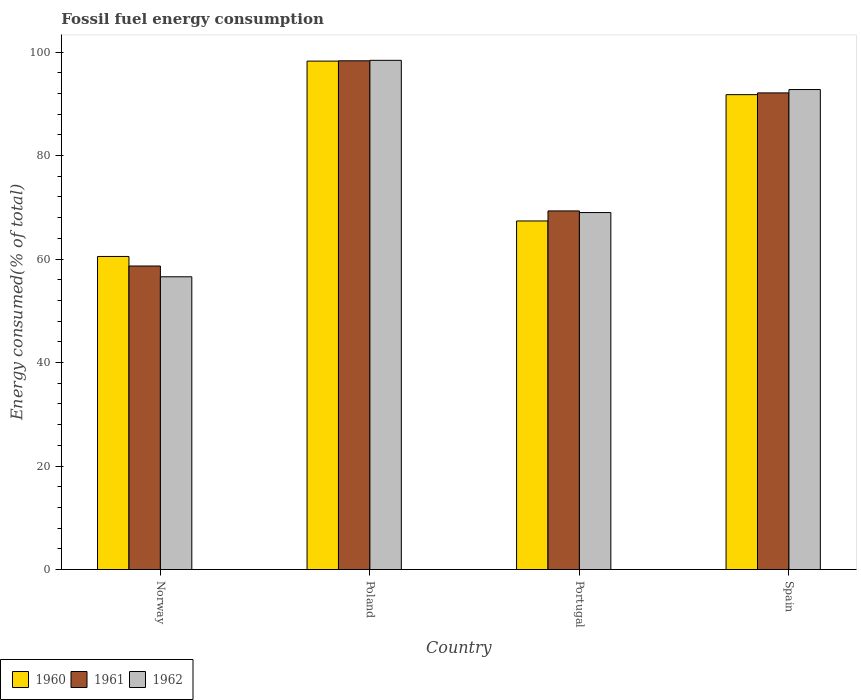How many different coloured bars are there?
Your answer should be very brief. 3. How many groups of bars are there?
Keep it short and to the point. 4. Are the number of bars per tick equal to the number of legend labels?
Offer a very short reply. Yes. Are the number of bars on each tick of the X-axis equal?
Provide a short and direct response. Yes. How many bars are there on the 1st tick from the right?
Provide a short and direct response. 3. In how many cases, is the number of bars for a given country not equal to the number of legend labels?
Make the answer very short. 0. What is the percentage of energy consumed in 1960 in Poland?
Your answer should be compact. 98.25. Across all countries, what is the maximum percentage of energy consumed in 1960?
Offer a terse response. 98.25. Across all countries, what is the minimum percentage of energy consumed in 1961?
Your answer should be very brief. 58.65. In which country was the percentage of energy consumed in 1961 minimum?
Your response must be concise. Norway. What is the total percentage of energy consumed in 1960 in the graph?
Ensure brevity in your answer.  317.87. What is the difference between the percentage of energy consumed in 1962 in Norway and that in Spain?
Your answer should be compact. -36.18. What is the difference between the percentage of energy consumed in 1962 in Poland and the percentage of energy consumed in 1960 in Spain?
Your response must be concise. 6.63. What is the average percentage of energy consumed in 1960 per country?
Give a very brief answer. 79.47. What is the difference between the percentage of energy consumed of/in 1962 and percentage of energy consumed of/in 1960 in Spain?
Give a very brief answer. 0.99. What is the ratio of the percentage of energy consumed in 1961 in Portugal to that in Spain?
Ensure brevity in your answer.  0.75. Is the difference between the percentage of energy consumed in 1962 in Norway and Spain greater than the difference between the percentage of energy consumed in 1960 in Norway and Spain?
Provide a succinct answer. No. What is the difference between the highest and the second highest percentage of energy consumed in 1961?
Keep it short and to the point. 6.2. What is the difference between the highest and the lowest percentage of energy consumed in 1960?
Keep it short and to the point. 37.75. In how many countries, is the percentage of energy consumed in 1962 greater than the average percentage of energy consumed in 1962 taken over all countries?
Your response must be concise. 2. What does the 2nd bar from the right in Norway represents?
Offer a terse response. 1961. Are all the bars in the graph horizontal?
Keep it short and to the point. No. What is the difference between two consecutive major ticks on the Y-axis?
Your answer should be very brief. 20. Are the values on the major ticks of Y-axis written in scientific E-notation?
Make the answer very short. No. Does the graph contain any zero values?
Provide a short and direct response. No. Where does the legend appear in the graph?
Your answer should be very brief. Bottom left. What is the title of the graph?
Provide a short and direct response. Fossil fuel energy consumption. Does "1965" appear as one of the legend labels in the graph?
Provide a short and direct response. No. What is the label or title of the X-axis?
Offer a terse response. Country. What is the label or title of the Y-axis?
Keep it short and to the point. Energy consumed(% of total). What is the Energy consumed(% of total) of 1960 in Norway?
Your answer should be compact. 60.5. What is the Energy consumed(% of total) of 1961 in Norway?
Keep it short and to the point. 58.65. What is the Energy consumed(% of total) in 1962 in Norway?
Provide a succinct answer. 56.57. What is the Energy consumed(% of total) of 1960 in Poland?
Your answer should be very brief. 98.25. What is the Energy consumed(% of total) in 1961 in Poland?
Provide a succinct answer. 98.3. What is the Energy consumed(% of total) of 1962 in Poland?
Ensure brevity in your answer.  98.4. What is the Energy consumed(% of total) of 1960 in Portugal?
Provide a succinct answer. 67.36. What is the Energy consumed(% of total) of 1961 in Portugal?
Offer a very short reply. 69.3. What is the Energy consumed(% of total) in 1962 in Portugal?
Provide a succinct answer. 68.98. What is the Energy consumed(% of total) in 1960 in Spain?
Offer a terse response. 91.77. What is the Energy consumed(% of total) of 1961 in Spain?
Provide a succinct answer. 92.1. What is the Energy consumed(% of total) of 1962 in Spain?
Keep it short and to the point. 92.75. Across all countries, what is the maximum Energy consumed(% of total) of 1960?
Offer a terse response. 98.25. Across all countries, what is the maximum Energy consumed(% of total) in 1961?
Offer a terse response. 98.3. Across all countries, what is the maximum Energy consumed(% of total) in 1962?
Make the answer very short. 98.4. Across all countries, what is the minimum Energy consumed(% of total) of 1960?
Your answer should be very brief. 60.5. Across all countries, what is the minimum Energy consumed(% of total) of 1961?
Offer a terse response. 58.65. Across all countries, what is the minimum Energy consumed(% of total) of 1962?
Keep it short and to the point. 56.57. What is the total Energy consumed(% of total) of 1960 in the graph?
Ensure brevity in your answer.  317.87. What is the total Energy consumed(% of total) of 1961 in the graph?
Your answer should be compact. 318.36. What is the total Energy consumed(% of total) of 1962 in the graph?
Make the answer very short. 316.7. What is the difference between the Energy consumed(% of total) in 1960 in Norway and that in Poland?
Provide a succinct answer. -37.75. What is the difference between the Energy consumed(% of total) in 1961 in Norway and that in Poland?
Keep it short and to the point. -39.65. What is the difference between the Energy consumed(% of total) in 1962 in Norway and that in Poland?
Your answer should be very brief. -41.83. What is the difference between the Energy consumed(% of total) in 1960 in Norway and that in Portugal?
Offer a terse response. -6.86. What is the difference between the Energy consumed(% of total) of 1961 in Norway and that in Portugal?
Your response must be concise. -10.64. What is the difference between the Energy consumed(% of total) of 1962 in Norway and that in Portugal?
Keep it short and to the point. -12.41. What is the difference between the Energy consumed(% of total) in 1960 in Norway and that in Spain?
Ensure brevity in your answer.  -31.27. What is the difference between the Energy consumed(% of total) in 1961 in Norway and that in Spain?
Keep it short and to the point. -33.45. What is the difference between the Energy consumed(% of total) in 1962 in Norway and that in Spain?
Keep it short and to the point. -36.18. What is the difference between the Energy consumed(% of total) in 1960 in Poland and that in Portugal?
Your answer should be very brief. 30.89. What is the difference between the Energy consumed(% of total) of 1961 in Poland and that in Portugal?
Your answer should be compact. 29.01. What is the difference between the Energy consumed(% of total) in 1962 in Poland and that in Portugal?
Your response must be concise. 29.42. What is the difference between the Energy consumed(% of total) of 1960 in Poland and that in Spain?
Offer a terse response. 6.48. What is the difference between the Energy consumed(% of total) in 1961 in Poland and that in Spain?
Ensure brevity in your answer.  6.2. What is the difference between the Energy consumed(% of total) in 1962 in Poland and that in Spain?
Give a very brief answer. 5.64. What is the difference between the Energy consumed(% of total) in 1960 in Portugal and that in Spain?
Ensure brevity in your answer.  -24.41. What is the difference between the Energy consumed(% of total) in 1961 in Portugal and that in Spain?
Provide a succinct answer. -22.81. What is the difference between the Energy consumed(% of total) of 1962 in Portugal and that in Spain?
Offer a very short reply. -23.77. What is the difference between the Energy consumed(% of total) in 1960 in Norway and the Energy consumed(% of total) in 1961 in Poland?
Make the answer very short. -37.81. What is the difference between the Energy consumed(% of total) of 1960 in Norway and the Energy consumed(% of total) of 1962 in Poland?
Provide a succinct answer. -37.9. What is the difference between the Energy consumed(% of total) of 1961 in Norway and the Energy consumed(% of total) of 1962 in Poland?
Ensure brevity in your answer.  -39.74. What is the difference between the Energy consumed(% of total) in 1960 in Norway and the Energy consumed(% of total) in 1961 in Portugal?
Offer a terse response. -8.8. What is the difference between the Energy consumed(% of total) in 1960 in Norway and the Energy consumed(% of total) in 1962 in Portugal?
Keep it short and to the point. -8.48. What is the difference between the Energy consumed(% of total) of 1961 in Norway and the Energy consumed(% of total) of 1962 in Portugal?
Offer a terse response. -10.33. What is the difference between the Energy consumed(% of total) of 1960 in Norway and the Energy consumed(% of total) of 1961 in Spain?
Offer a terse response. -31.61. What is the difference between the Energy consumed(% of total) in 1960 in Norway and the Energy consumed(% of total) in 1962 in Spain?
Offer a terse response. -32.26. What is the difference between the Energy consumed(% of total) in 1961 in Norway and the Energy consumed(% of total) in 1962 in Spain?
Provide a succinct answer. -34.1. What is the difference between the Energy consumed(% of total) of 1960 in Poland and the Energy consumed(% of total) of 1961 in Portugal?
Provide a short and direct response. 28.95. What is the difference between the Energy consumed(% of total) in 1960 in Poland and the Energy consumed(% of total) in 1962 in Portugal?
Keep it short and to the point. 29.27. What is the difference between the Energy consumed(% of total) in 1961 in Poland and the Energy consumed(% of total) in 1962 in Portugal?
Provide a short and direct response. 29.32. What is the difference between the Energy consumed(% of total) in 1960 in Poland and the Energy consumed(% of total) in 1961 in Spain?
Provide a short and direct response. 6.14. What is the difference between the Energy consumed(% of total) of 1960 in Poland and the Energy consumed(% of total) of 1962 in Spain?
Your answer should be compact. 5.49. What is the difference between the Energy consumed(% of total) in 1961 in Poland and the Energy consumed(% of total) in 1962 in Spain?
Your answer should be compact. 5.55. What is the difference between the Energy consumed(% of total) of 1960 in Portugal and the Energy consumed(% of total) of 1961 in Spain?
Provide a short and direct response. -24.75. What is the difference between the Energy consumed(% of total) of 1960 in Portugal and the Energy consumed(% of total) of 1962 in Spain?
Your response must be concise. -25.4. What is the difference between the Energy consumed(% of total) in 1961 in Portugal and the Energy consumed(% of total) in 1962 in Spain?
Your answer should be compact. -23.46. What is the average Energy consumed(% of total) of 1960 per country?
Offer a terse response. 79.47. What is the average Energy consumed(% of total) in 1961 per country?
Give a very brief answer. 79.59. What is the average Energy consumed(% of total) in 1962 per country?
Ensure brevity in your answer.  79.17. What is the difference between the Energy consumed(% of total) of 1960 and Energy consumed(% of total) of 1961 in Norway?
Provide a succinct answer. 1.85. What is the difference between the Energy consumed(% of total) of 1960 and Energy consumed(% of total) of 1962 in Norway?
Provide a short and direct response. 3.93. What is the difference between the Energy consumed(% of total) in 1961 and Energy consumed(% of total) in 1962 in Norway?
Your answer should be compact. 2.08. What is the difference between the Energy consumed(% of total) in 1960 and Energy consumed(% of total) in 1961 in Poland?
Ensure brevity in your answer.  -0.06. What is the difference between the Energy consumed(% of total) in 1960 and Energy consumed(% of total) in 1962 in Poland?
Your response must be concise. -0.15. What is the difference between the Energy consumed(% of total) of 1961 and Energy consumed(% of total) of 1962 in Poland?
Offer a terse response. -0.09. What is the difference between the Energy consumed(% of total) of 1960 and Energy consumed(% of total) of 1961 in Portugal?
Provide a short and direct response. -1.94. What is the difference between the Energy consumed(% of total) of 1960 and Energy consumed(% of total) of 1962 in Portugal?
Make the answer very short. -1.62. What is the difference between the Energy consumed(% of total) of 1961 and Energy consumed(% of total) of 1962 in Portugal?
Ensure brevity in your answer.  0.32. What is the difference between the Energy consumed(% of total) in 1960 and Energy consumed(% of total) in 1961 in Spain?
Your response must be concise. -0.34. What is the difference between the Energy consumed(% of total) of 1960 and Energy consumed(% of total) of 1962 in Spain?
Offer a terse response. -0.99. What is the difference between the Energy consumed(% of total) in 1961 and Energy consumed(% of total) in 1962 in Spain?
Offer a terse response. -0.65. What is the ratio of the Energy consumed(% of total) of 1960 in Norway to that in Poland?
Make the answer very short. 0.62. What is the ratio of the Energy consumed(% of total) in 1961 in Norway to that in Poland?
Your answer should be very brief. 0.6. What is the ratio of the Energy consumed(% of total) in 1962 in Norway to that in Poland?
Offer a terse response. 0.57. What is the ratio of the Energy consumed(% of total) in 1960 in Norway to that in Portugal?
Keep it short and to the point. 0.9. What is the ratio of the Energy consumed(% of total) of 1961 in Norway to that in Portugal?
Offer a very short reply. 0.85. What is the ratio of the Energy consumed(% of total) of 1962 in Norway to that in Portugal?
Your answer should be very brief. 0.82. What is the ratio of the Energy consumed(% of total) of 1960 in Norway to that in Spain?
Offer a very short reply. 0.66. What is the ratio of the Energy consumed(% of total) in 1961 in Norway to that in Spain?
Offer a terse response. 0.64. What is the ratio of the Energy consumed(% of total) of 1962 in Norway to that in Spain?
Ensure brevity in your answer.  0.61. What is the ratio of the Energy consumed(% of total) in 1960 in Poland to that in Portugal?
Your answer should be very brief. 1.46. What is the ratio of the Energy consumed(% of total) in 1961 in Poland to that in Portugal?
Ensure brevity in your answer.  1.42. What is the ratio of the Energy consumed(% of total) of 1962 in Poland to that in Portugal?
Your answer should be very brief. 1.43. What is the ratio of the Energy consumed(% of total) in 1960 in Poland to that in Spain?
Your answer should be very brief. 1.07. What is the ratio of the Energy consumed(% of total) of 1961 in Poland to that in Spain?
Your answer should be very brief. 1.07. What is the ratio of the Energy consumed(% of total) of 1962 in Poland to that in Spain?
Provide a succinct answer. 1.06. What is the ratio of the Energy consumed(% of total) in 1960 in Portugal to that in Spain?
Your answer should be very brief. 0.73. What is the ratio of the Energy consumed(% of total) in 1961 in Portugal to that in Spain?
Keep it short and to the point. 0.75. What is the ratio of the Energy consumed(% of total) in 1962 in Portugal to that in Spain?
Provide a succinct answer. 0.74. What is the difference between the highest and the second highest Energy consumed(% of total) of 1960?
Offer a terse response. 6.48. What is the difference between the highest and the second highest Energy consumed(% of total) in 1961?
Provide a succinct answer. 6.2. What is the difference between the highest and the second highest Energy consumed(% of total) of 1962?
Provide a succinct answer. 5.64. What is the difference between the highest and the lowest Energy consumed(% of total) of 1960?
Ensure brevity in your answer.  37.75. What is the difference between the highest and the lowest Energy consumed(% of total) of 1961?
Offer a very short reply. 39.65. What is the difference between the highest and the lowest Energy consumed(% of total) of 1962?
Offer a terse response. 41.83. 